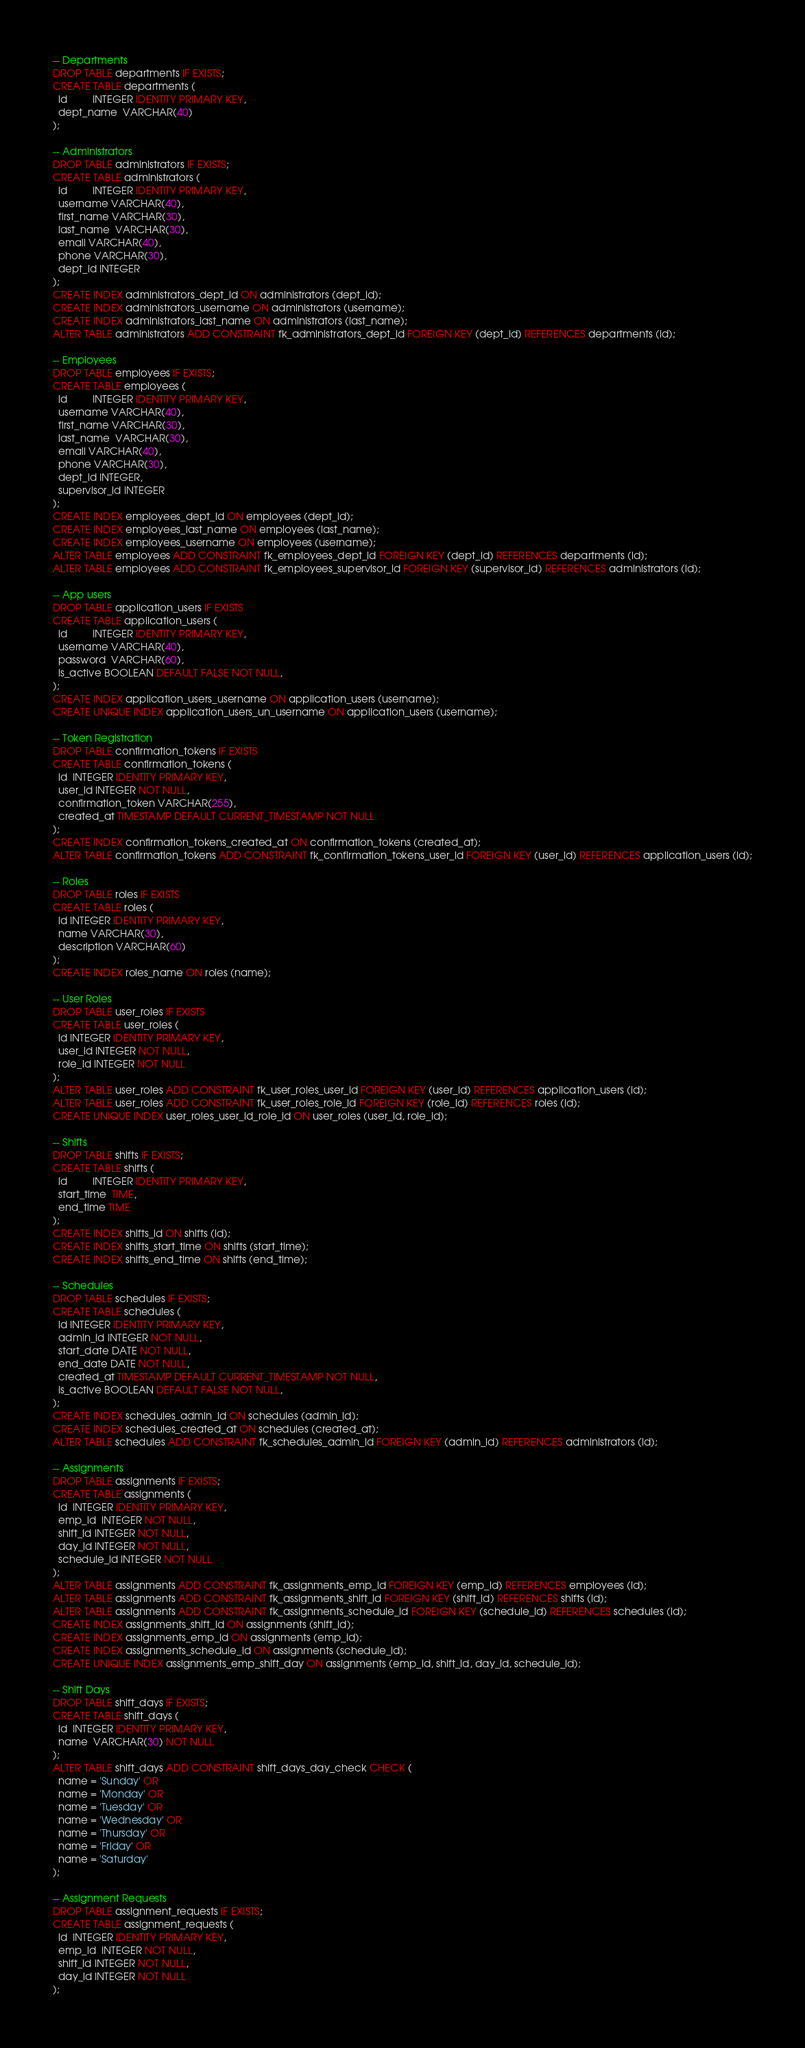Convert code to text. <code><loc_0><loc_0><loc_500><loc_500><_SQL_>-- Departments
DROP TABLE departments IF EXISTS;
CREATE TABLE departments (
  id         INTEGER IDENTITY PRIMARY KEY,
  dept_name  VARCHAR(40)
);

-- Administrators
DROP TABLE administrators IF EXISTS;
CREATE TABLE administrators (
  id         INTEGER IDENTITY PRIMARY KEY,
  username VARCHAR(40),
  first_name VARCHAR(30),
  last_name  VARCHAR(30),
  email VARCHAR(40),
  phone VARCHAR(30),
  dept_id INTEGER
);
CREATE INDEX administrators_dept_id ON administrators (dept_id);
CREATE INDEX administrators_username ON administrators (username);
CREATE INDEX administrators_last_name ON administrators (last_name);
ALTER TABLE administrators ADD CONSTRAINT fk_administrators_dept_id FOREIGN KEY (dept_id) REFERENCES departments (id);

-- Employees
DROP TABLE employees IF EXISTS;
CREATE TABLE employees (
  id         INTEGER IDENTITY PRIMARY KEY,
  username VARCHAR(40),
  first_name VARCHAR(30),
  last_name  VARCHAR(30),
  email VARCHAR(40),
  phone VARCHAR(30),
  dept_id INTEGER,
  supervisor_id INTEGER
);
CREATE INDEX employees_dept_id ON employees (dept_id);
CREATE INDEX employees_last_name ON employees (last_name);
CREATE INDEX employees_username ON employees (username);
ALTER TABLE employees ADD CONSTRAINT fk_employees_dept_id FOREIGN KEY (dept_id) REFERENCES departments (id);
ALTER TABLE employees ADD CONSTRAINT fk_employees_supervisor_id FOREIGN KEY (supervisor_id) REFERENCES administrators (id);

-- App users
DROP TABLE application_users IF EXISTS
CREATE TABLE application_users (
  id         INTEGER IDENTITY PRIMARY KEY,
  username VARCHAR(40),
  password  VARCHAR(60),
  is_active BOOLEAN DEFAULT FALSE NOT NULL,
);
CREATE INDEX application_users_username ON application_users (username);
CREATE UNIQUE INDEX application_users_un_username ON application_users (username);

-- Token Registration
DROP TABLE confirmation_tokens IF EXISTS
CREATE TABLE confirmation_tokens (
  id  INTEGER IDENTITY PRIMARY KEY,
  user_id INTEGER NOT NULL,
  confirmation_token VARCHAR(255),
  created_at TIMESTAMP DEFAULT CURRENT_TIMESTAMP NOT NULL
);
CREATE INDEX confirmation_tokens_created_at ON confirmation_tokens (created_at);
ALTER TABLE confirmation_tokens ADD CONSTRAINT fk_confirmation_tokens_user_id FOREIGN KEY (user_id) REFERENCES application_users (id);

-- Roles
DROP TABLE roles IF EXISTS 
CREATE TABLE roles (
  id INTEGER IDENTITY PRIMARY KEY,
  name VARCHAR(30),
  description VARCHAR(60)
);
CREATE INDEX roles_name ON roles (name);

-- User Roles
DROP TABLE user_roles IF EXISTS 
CREATE TABLE user_roles (
  id INTEGER IDENTITY PRIMARY KEY,
  user_id INTEGER NOT NULL,
  role_id INTEGER NOT NULL
);
ALTER TABLE user_roles ADD CONSTRAINT fk_user_roles_user_id FOREIGN KEY (user_id) REFERENCES application_users (id);
ALTER TABLE user_roles ADD CONSTRAINT fk_user_roles_role_id FOREIGN KEY (role_id) REFERENCES roles (id);
CREATE UNIQUE INDEX user_roles_user_id_role_id ON user_roles (user_id, role_id);

-- Shifts
DROP TABLE shifts IF EXISTS;
CREATE TABLE shifts (
  id         INTEGER IDENTITY PRIMARY KEY,
  start_time  TIME,
  end_time TIME
);
CREATE INDEX shifts_id ON shifts (id);
CREATE INDEX shifts_start_time ON shifts (start_time);
CREATE INDEX shifts_end_time ON shifts (end_time);

-- Schedules
DROP TABLE schedules IF EXISTS; 
CREATE TABLE schedules (
  id INTEGER IDENTITY PRIMARY KEY,
  admin_id INTEGER NOT NULL,
  start_date DATE NOT NULL,
  end_date DATE NOT NULL,
  created_at TIMESTAMP DEFAULT CURRENT_TIMESTAMP NOT NULL,
  is_active BOOLEAN DEFAULT FALSE NOT NULL,
);
CREATE INDEX schedules_admin_id ON schedules (admin_id);
CREATE INDEX schedules_created_at ON schedules (created_at);
ALTER TABLE schedules ADD CONSTRAINT fk_schedules_admin_id FOREIGN KEY (admin_id) REFERENCES administrators (id);

-- Assignments
DROP TABLE assignments IF EXISTS;
CREATE TABLE assignments (
  id  INTEGER IDENTITY PRIMARY KEY,
  emp_id  INTEGER NOT NULL,
  shift_id INTEGER NOT NULL,
  day_id INTEGER NOT NULL,
  schedule_id INTEGER NOT NULL
);
ALTER TABLE assignments ADD CONSTRAINT fk_assignments_emp_id FOREIGN KEY (emp_id) REFERENCES employees (id);
ALTER TABLE assignments ADD CONSTRAINT fk_assignments_shift_id FOREIGN KEY (shift_id) REFERENCES shifts (id);
ALTER TABLE assignments ADD CONSTRAINT fk_assignments_schedule_id FOREIGN KEY (schedule_id) REFERENCES schedules (id);
CREATE INDEX assignments_shift_id ON assignments (shift_id);
CREATE INDEX assignments_emp_id ON assignments (emp_id);
CREATE INDEX assignments_schedule_id ON assignments (schedule_id);
CREATE UNIQUE INDEX assignments_emp_shift_day ON assignments (emp_id, shift_id, day_id, schedule_id);

-- Shift Days
DROP TABLE shift_days IF EXISTS;
CREATE TABLE shift_days (
  id  INTEGER IDENTITY PRIMARY KEY,
  name  VARCHAR(30) NOT NULL
);
ALTER TABLE shift_days ADD CONSTRAINT shift_days_day_check CHECK (
  name = 'Sunday' OR
  name = 'Monday' OR
  name = 'Tuesday' OR
  name = 'Wednesday' OR
  name = 'Thursday' OR
  name = 'Friday' OR
  name = 'Saturday'
);

-- Assignment Requests
DROP TABLE assignment_requests IF EXISTS;
CREATE TABLE assignment_requests (
  id  INTEGER IDENTITY PRIMARY KEY,
  emp_id  INTEGER NOT NULL,
  shift_id INTEGER NOT NULL,
  day_id INTEGER NOT NULL
);</code> 